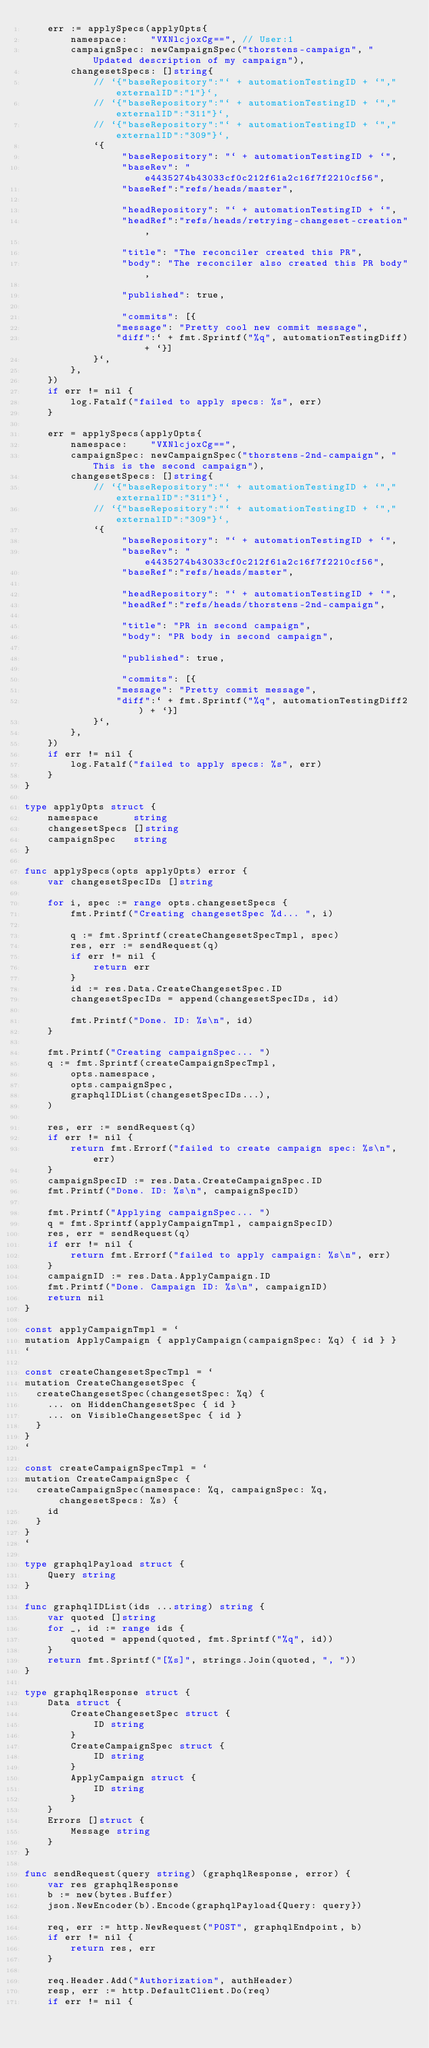<code> <loc_0><loc_0><loc_500><loc_500><_Go_>	err := applySpecs(applyOpts{
		namespace:    "VXNlcjoxCg==", // User:1
		campaignSpec: newCampaignSpec("thorstens-campaign", "Updated description of my campaign"),
		changesetSpecs: []string{
			// `{"baseRepository":"` + automationTestingID + `","externalID":"1"}`,
			// `{"baseRepository":"` + automationTestingID + `","externalID":"311"}`,
			// `{"baseRepository":"` + automationTestingID + `","externalID":"309"}`,
			`{
			     "baseRepository": "` + automationTestingID + `",
			     "baseRev": "e4435274b43033cf0c212f61a2c16f7f2210cf56",
			     "baseRef":"refs/heads/master",

			     "headRepository": "` + automationTestingID + `",
			     "headRef":"refs/heads/retrying-changeset-creation",

			     "title": "The reconciler created this PR",
			     "body": "The reconciler also created this PR body",

			     "published": true,

			     "commits": [{
			    "message": "Pretty cool new commit message",
				"diff":` + fmt.Sprintf("%q", automationTestingDiff) + `}]
			}`,
		},
	})
	if err != nil {
		log.Fatalf("failed to apply specs: %s", err)
	}

	err = applySpecs(applyOpts{
		namespace:    "VXNlcjoxCg==",
		campaignSpec: newCampaignSpec("thorstens-2nd-campaign", "This is the second campaign"),
		changesetSpecs: []string{
			// `{"baseRepository":"` + automationTestingID + `","externalID":"311"}`,
			// `{"baseRepository":"` + automationTestingID + `","externalID":"309"}`,
			`{
			     "baseRepository": "` + automationTestingID + `",
			     "baseRev": "e4435274b43033cf0c212f61a2c16f7f2210cf56",
			     "baseRef":"refs/heads/master",

			     "headRepository": "` + automationTestingID + `",
			     "headRef":"refs/heads/thorstens-2nd-campaign",

			     "title": "PR in second campaign",
			     "body": "PR body in second campaign",

			     "published": true,

			     "commits": [{
			    "message": "Pretty commit message",
				"diff":` + fmt.Sprintf("%q", automationTestingDiff2) + `}]
			}`,
		},
	})
	if err != nil {
		log.Fatalf("failed to apply specs: %s", err)
	}
}

type applyOpts struct {
	namespace      string
	changesetSpecs []string
	campaignSpec   string
}

func applySpecs(opts applyOpts) error {
	var changesetSpecIDs []string

	for i, spec := range opts.changesetSpecs {
		fmt.Printf("Creating changesetSpec %d... ", i)

		q := fmt.Sprintf(createChangesetSpecTmpl, spec)
		res, err := sendRequest(q)
		if err != nil {
			return err
		}
		id := res.Data.CreateChangesetSpec.ID
		changesetSpecIDs = append(changesetSpecIDs, id)

		fmt.Printf("Done. ID: %s\n", id)
	}

	fmt.Printf("Creating campaignSpec... ")
	q := fmt.Sprintf(createCampaignSpecTmpl,
		opts.namespace,
		opts.campaignSpec,
		graphqlIDList(changesetSpecIDs...),
	)

	res, err := sendRequest(q)
	if err != nil {
		return fmt.Errorf("failed to create campaign spec: %s\n", err)
	}
	campaignSpecID := res.Data.CreateCampaignSpec.ID
	fmt.Printf("Done. ID: %s\n", campaignSpecID)

	fmt.Printf("Applying campaignSpec... ")
	q = fmt.Sprintf(applyCampaignTmpl, campaignSpecID)
	res, err = sendRequest(q)
	if err != nil {
		return fmt.Errorf("failed to apply campaign: %s\n", err)
	}
	campaignID := res.Data.ApplyCampaign.ID
	fmt.Printf("Done. Campaign ID: %s\n", campaignID)
	return nil
}

const applyCampaignTmpl = `
mutation ApplyCampaign { applyCampaign(campaignSpec: %q) { id } }
`

const createChangesetSpecTmpl = `
mutation CreateChangesetSpec {
  createChangesetSpec(changesetSpec: %q) {
    ... on HiddenChangesetSpec { id }
    ... on VisibleChangesetSpec { id }
  }
}
`

const createCampaignSpecTmpl = `
mutation CreateCampaignSpec {
  createCampaignSpec(namespace: %q, campaignSpec: %q, changesetSpecs: %s) {
    id
  }
}
`

type graphqlPayload struct {
	Query string
}

func graphqlIDList(ids ...string) string {
	var quoted []string
	for _, id := range ids {
		quoted = append(quoted, fmt.Sprintf("%q", id))
	}
	return fmt.Sprintf("[%s]", strings.Join(quoted, ", "))
}

type graphqlResponse struct {
	Data struct {
		CreateChangesetSpec struct {
			ID string
		}
		CreateCampaignSpec struct {
			ID string
		}
		ApplyCampaign struct {
			ID string
		}
	}
	Errors []struct {
		Message string
	}
}

func sendRequest(query string) (graphqlResponse, error) {
	var res graphqlResponse
	b := new(bytes.Buffer)
	json.NewEncoder(b).Encode(graphqlPayload{Query: query})

	req, err := http.NewRequest("POST", graphqlEndpoint, b)
	if err != nil {
		return res, err
	}

	req.Header.Add("Authorization", authHeader)
	resp, err := http.DefaultClient.Do(req)
	if err != nil {</code> 